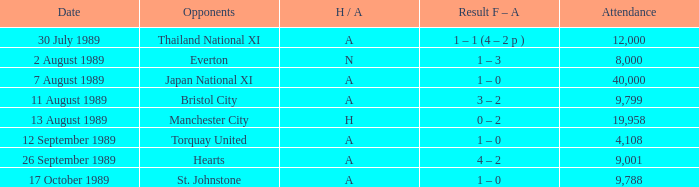When manchester united competed against the hearts, what was the attendance count for the match? 9001.0. 